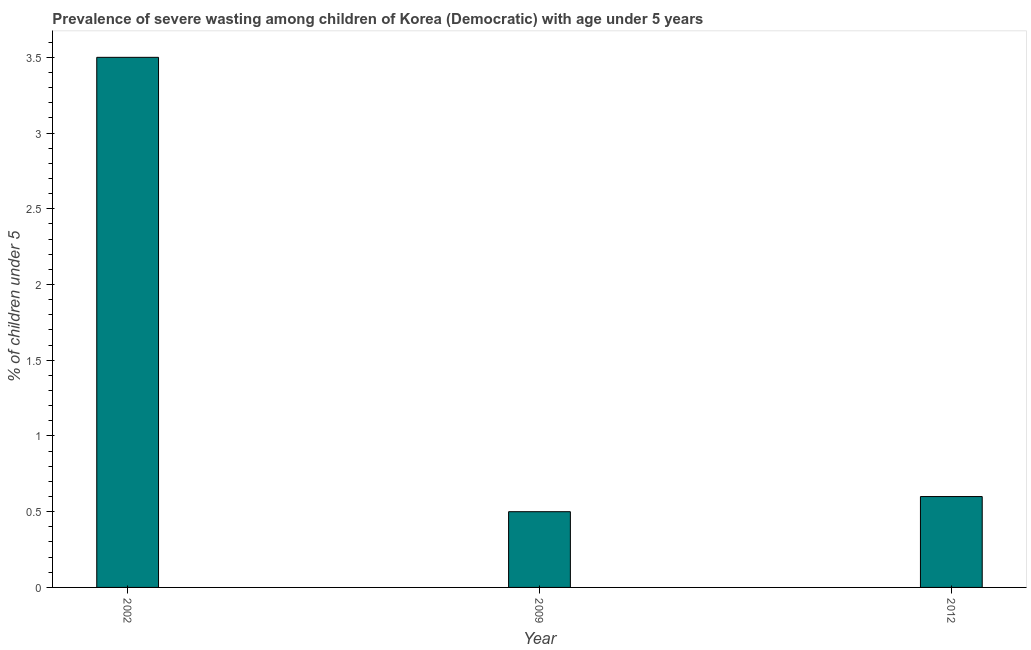Does the graph contain grids?
Your response must be concise. No. What is the title of the graph?
Offer a very short reply. Prevalence of severe wasting among children of Korea (Democratic) with age under 5 years. What is the label or title of the X-axis?
Your answer should be very brief. Year. What is the label or title of the Y-axis?
Offer a terse response.  % of children under 5. What is the prevalence of severe wasting in 2009?
Your answer should be very brief. 0.5. Across all years, what is the maximum prevalence of severe wasting?
Ensure brevity in your answer.  3.5. What is the sum of the prevalence of severe wasting?
Ensure brevity in your answer.  4.6. What is the average prevalence of severe wasting per year?
Ensure brevity in your answer.  1.53. What is the median prevalence of severe wasting?
Ensure brevity in your answer.  0.6. In how many years, is the prevalence of severe wasting greater than 3.3 %?
Your answer should be compact. 1. Do a majority of the years between 2009 and 2012 (inclusive) have prevalence of severe wasting greater than 3.1 %?
Keep it short and to the point. No. What is the ratio of the prevalence of severe wasting in 2002 to that in 2009?
Give a very brief answer. 7. Is the difference between the prevalence of severe wasting in 2002 and 2009 greater than the difference between any two years?
Give a very brief answer. Yes. What is the difference between the highest and the second highest prevalence of severe wasting?
Offer a very short reply. 2.9. Is the sum of the prevalence of severe wasting in 2002 and 2009 greater than the maximum prevalence of severe wasting across all years?
Provide a short and direct response. Yes. In how many years, is the prevalence of severe wasting greater than the average prevalence of severe wasting taken over all years?
Provide a succinct answer. 1. How many bars are there?
Your answer should be compact. 3. What is the difference between two consecutive major ticks on the Y-axis?
Keep it short and to the point. 0.5. What is the  % of children under 5 of 2002?
Give a very brief answer. 3.5. What is the  % of children under 5 in 2012?
Your response must be concise. 0.6. What is the difference between the  % of children under 5 in 2002 and 2009?
Your answer should be compact. 3. What is the difference between the  % of children under 5 in 2009 and 2012?
Your answer should be very brief. -0.1. What is the ratio of the  % of children under 5 in 2002 to that in 2009?
Your response must be concise. 7. What is the ratio of the  % of children under 5 in 2002 to that in 2012?
Your answer should be very brief. 5.83. What is the ratio of the  % of children under 5 in 2009 to that in 2012?
Keep it short and to the point. 0.83. 